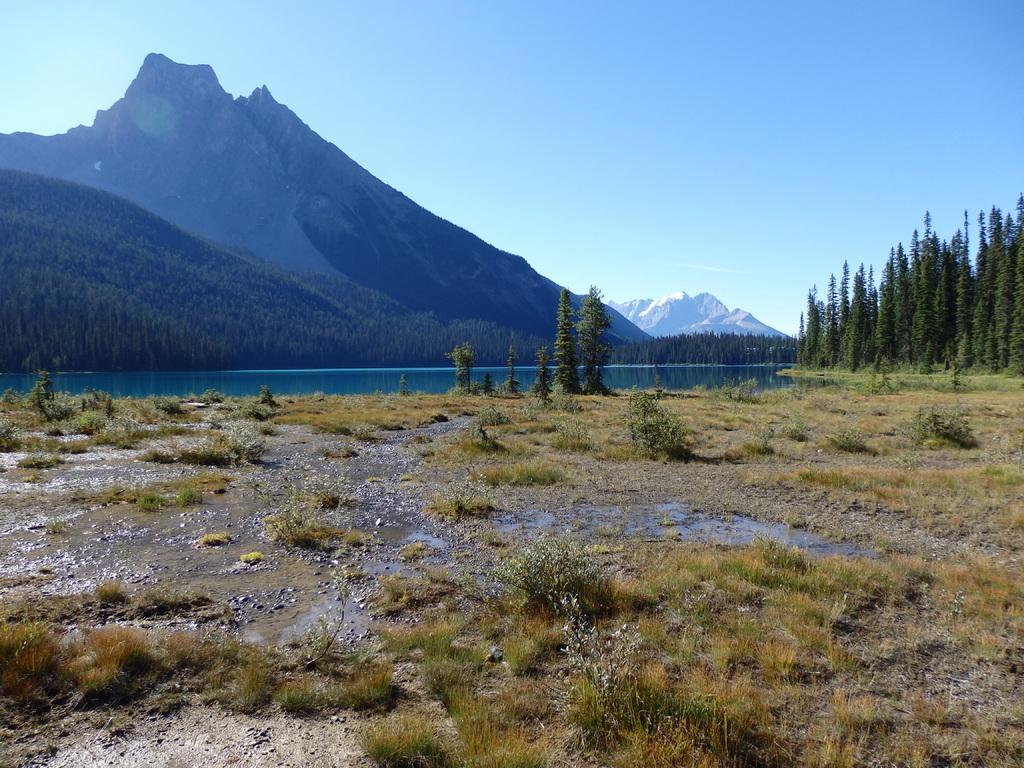In one or two sentences, can you explain what this image depicts? In this image, we can see some trees and plants. There is a lake and some hills in the middle of the image. There is a sky at the top of the image. 